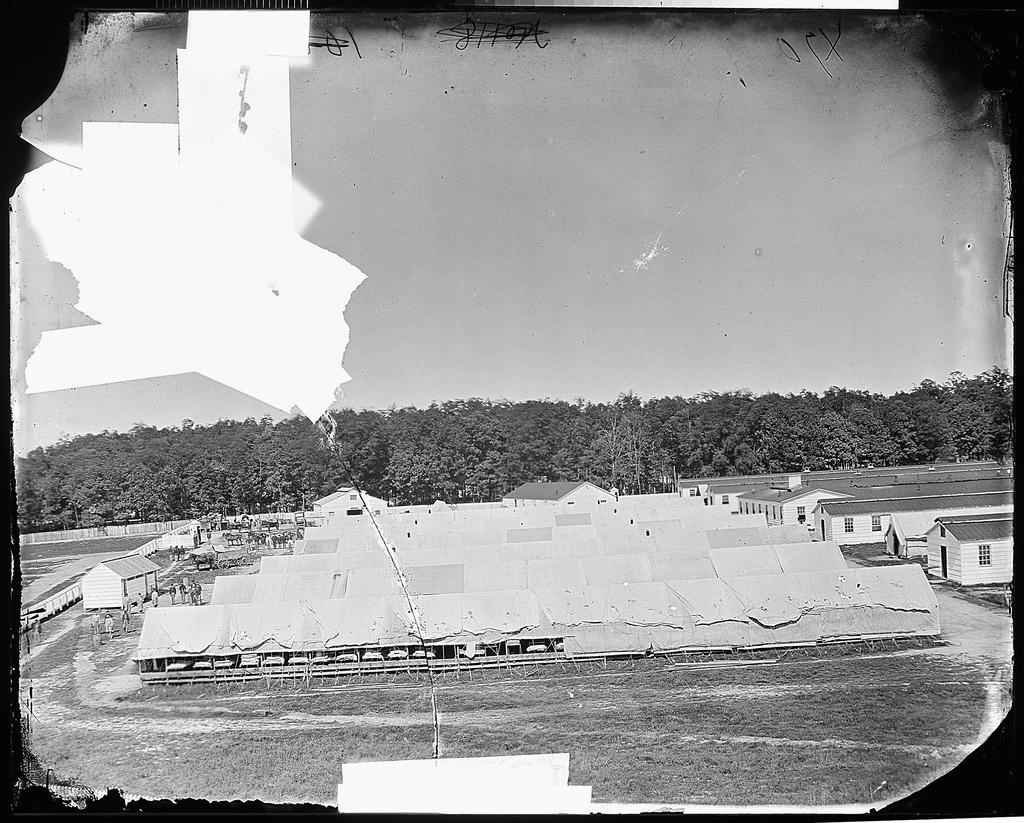What is the color scheme of the image? The image is black and white. What type of structures can be seen in the image? There are houses in the image. Who or what else is present in the image? There are people and trees in the image. What is the purpose of the fence in the image? The fence is likely used to separate or enclose areas in the image. What is visible beneath the people and structures in the image? The ground is visible in the image. How many holes can be seen in the image? There are no holes visible in the image. What type of drink is being consumed by the people in the image? There is no drink being consumed by the people in the image; it is a black and white image with no visible liquids. 